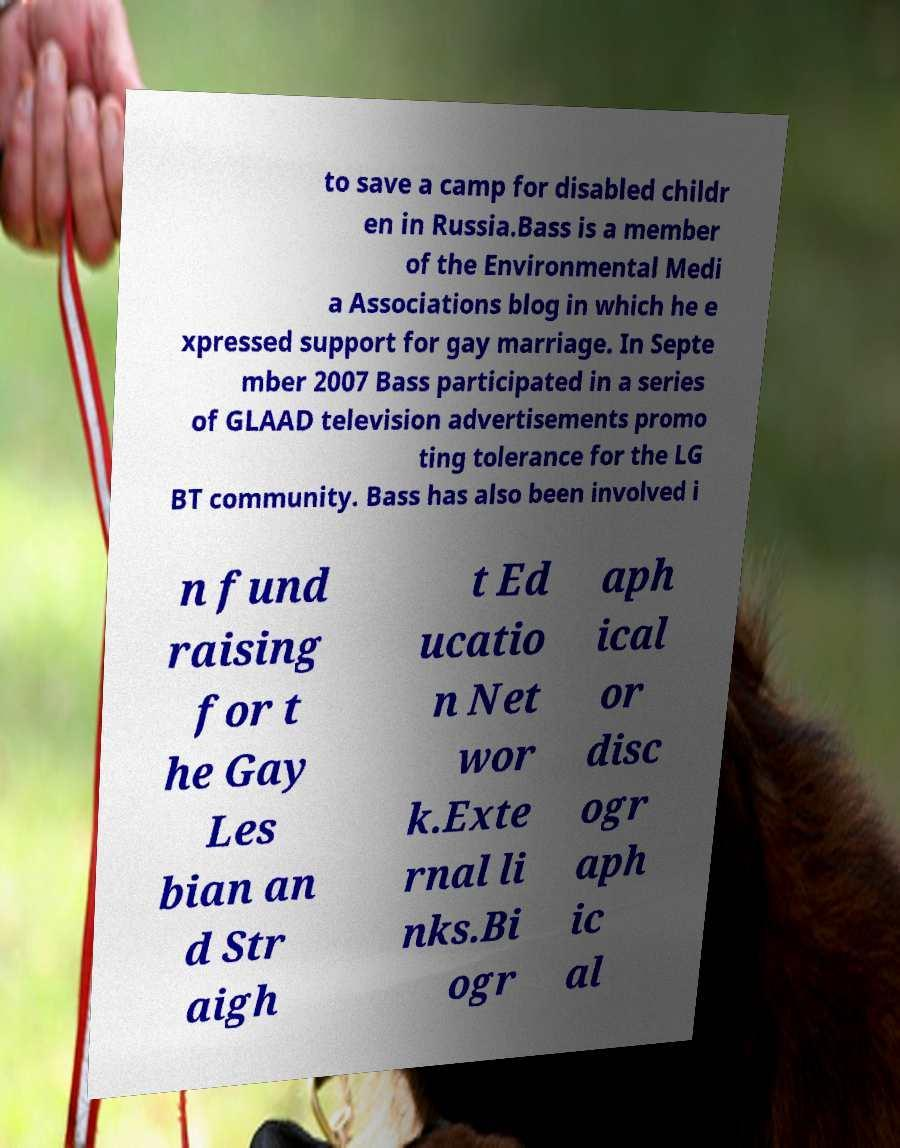Please read and relay the text visible in this image. What does it say? to save a camp for disabled childr en in Russia.Bass is a member of the Environmental Medi a Associations blog in which he e xpressed support for gay marriage. In Septe mber 2007 Bass participated in a series of GLAAD television advertisements promo ting tolerance for the LG BT community. Bass has also been involved i n fund raising for t he Gay Les bian an d Str aigh t Ed ucatio n Net wor k.Exte rnal li nks.Bi ogr aph ical or disc ogr aph ic al 